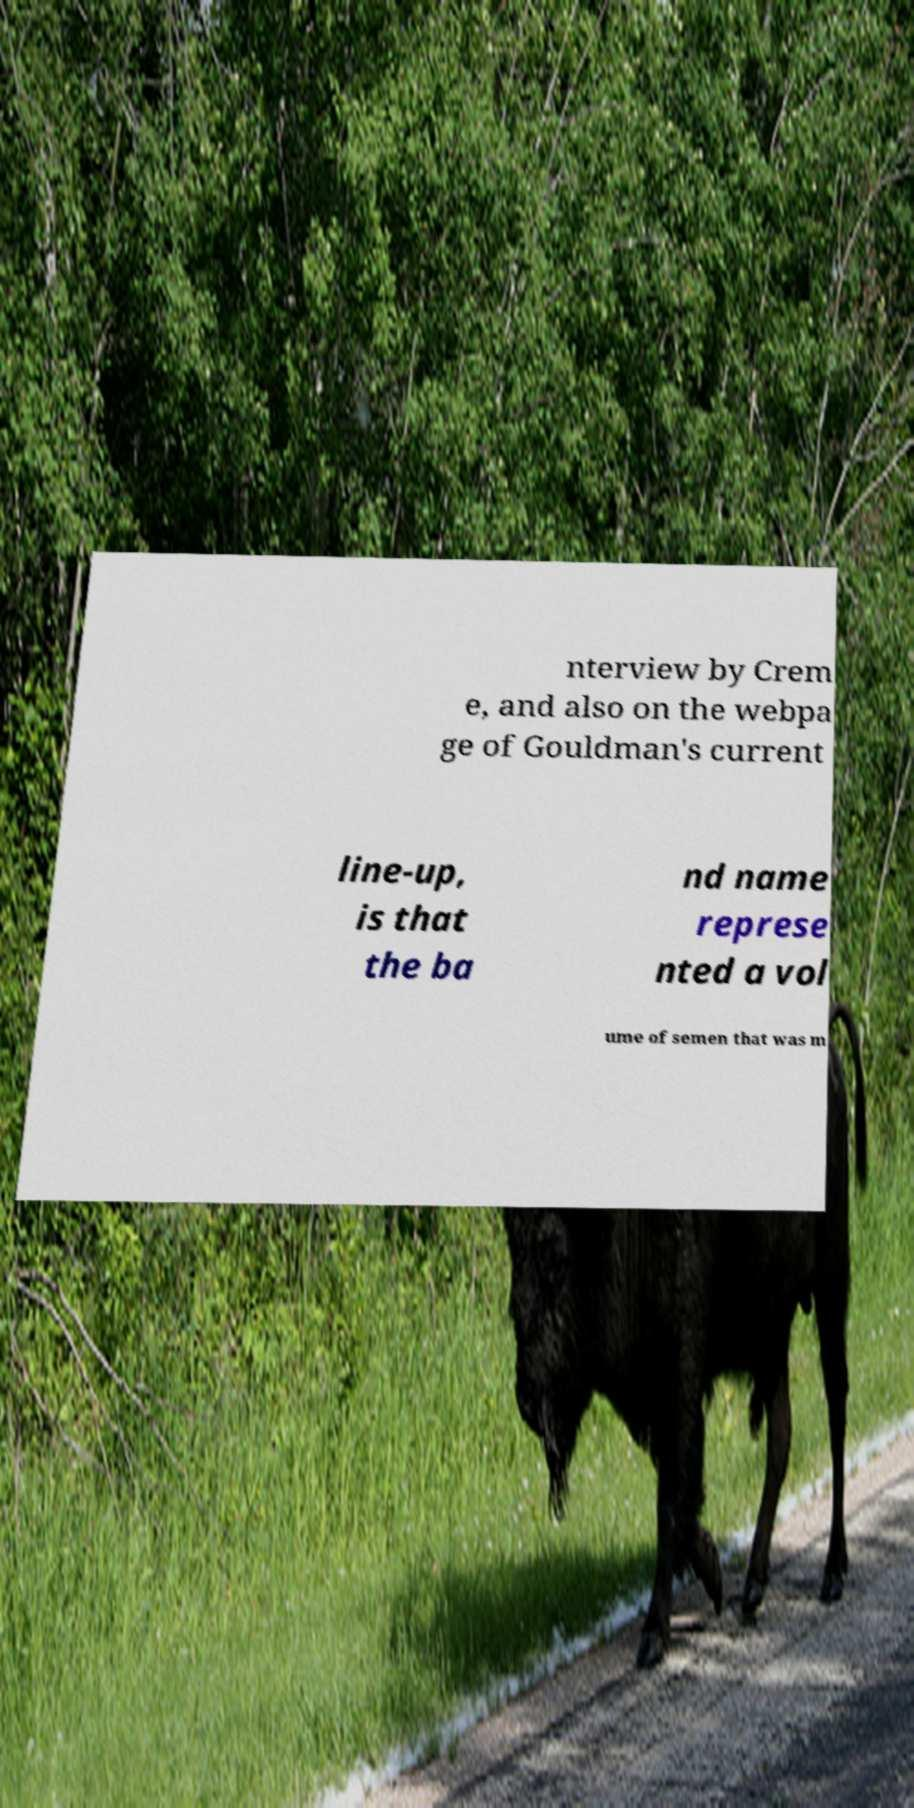Could you extract and type out the text from this image? nterview by Crem e, and also on the webpa ge of Gouldman's current line-up, is that the ba nd name represe nted a vol ume of semen that was m 